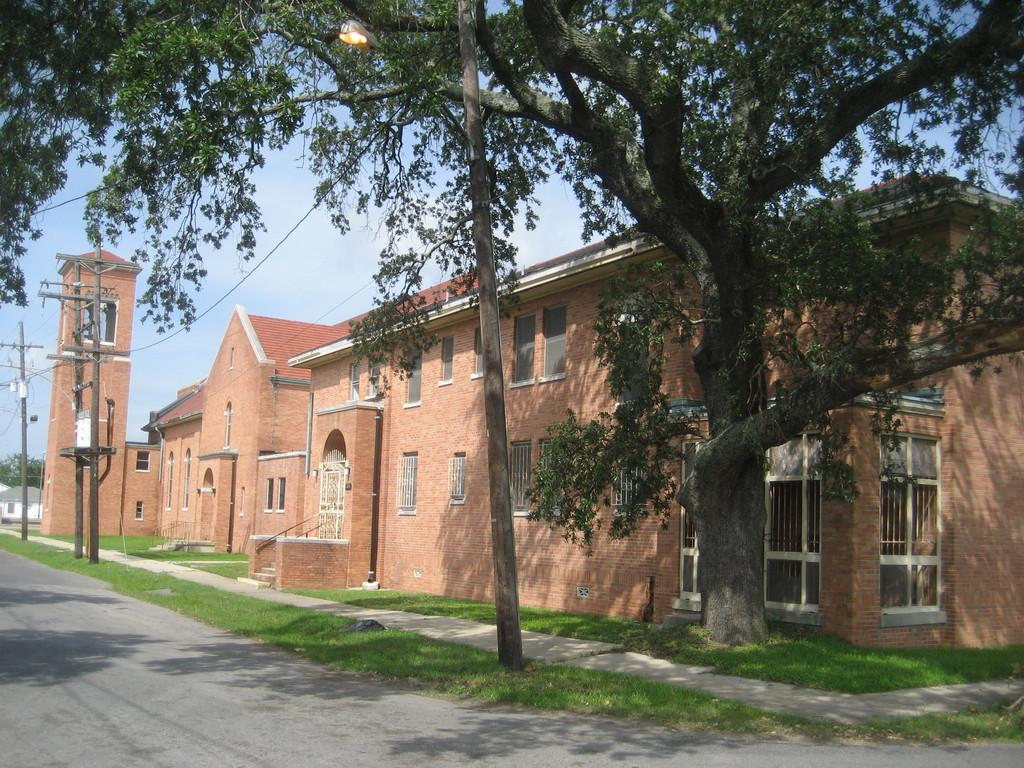What type of structure is located beside the road in the image? There is a building beside the road in the image. What else can be seen along the road in the image? There are electrical poles in the image. What type of natural elements are present in the image? There are trees in the image. What advice does the grandmother give to the girl in the image? There is no grandmother or girl present in the image; it only features a building, electrical poles, and trees. How does the care for the trees in the image differ from traditional care methods? There is no indication of any care being provided to the trees in the image, nor are there any alternative care methods mentioned. 